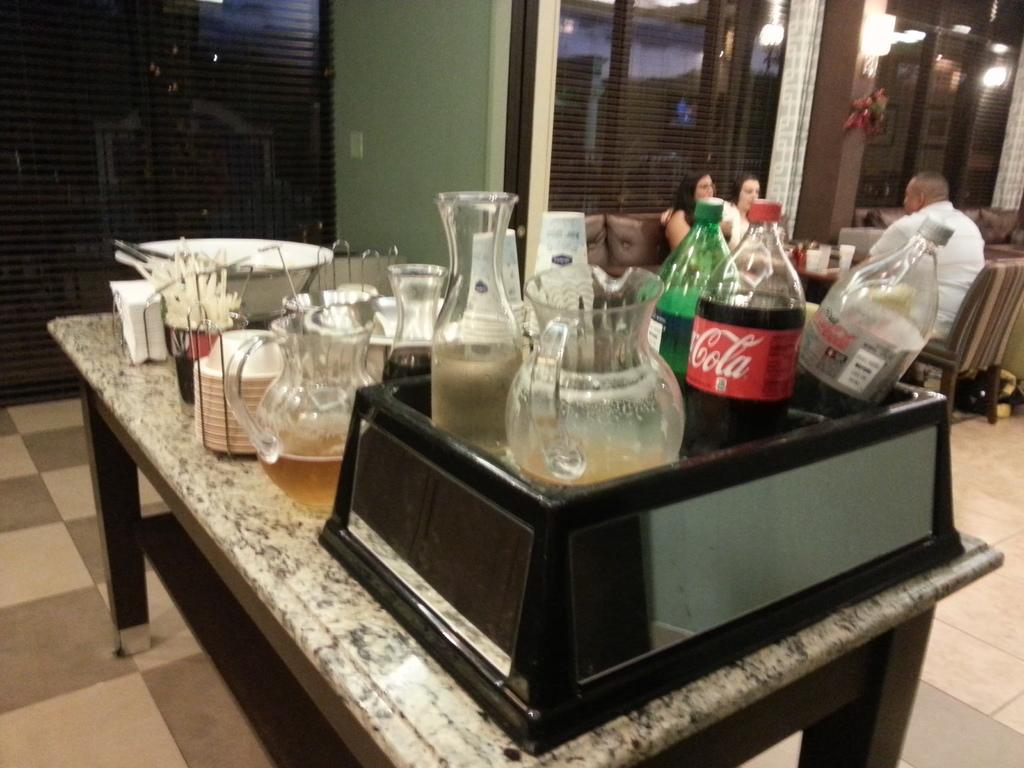Describe this image in one or two sentences. In the center we can see table,on table there is a water bottles,mug,plates,tissue papers,bowl and flower vase. In the background there is a wall,light and three persons were sitting on the couch. 